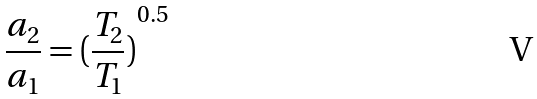<formula> <loc_0><loc_0><loc_500><loc_500>\frac { a _ { 2 } } { a _ { 1 } } = { ( \frac { T _ { 2 } } { T _ { 1 } } ) } ^ { 0 . 5 }</formula> 